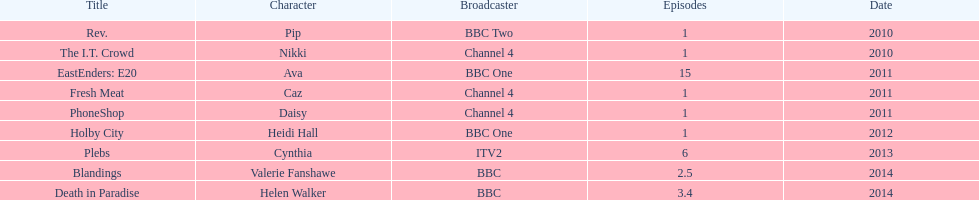Which characters were showcased in over one episode? Ava, Cynthia, Valerie Fanshawe, Helen Walker. Which of these instances were not in 2014? Ava, Cynthia. Which one of those wasn't presented on a bbc broadcaster? Cynthia. 